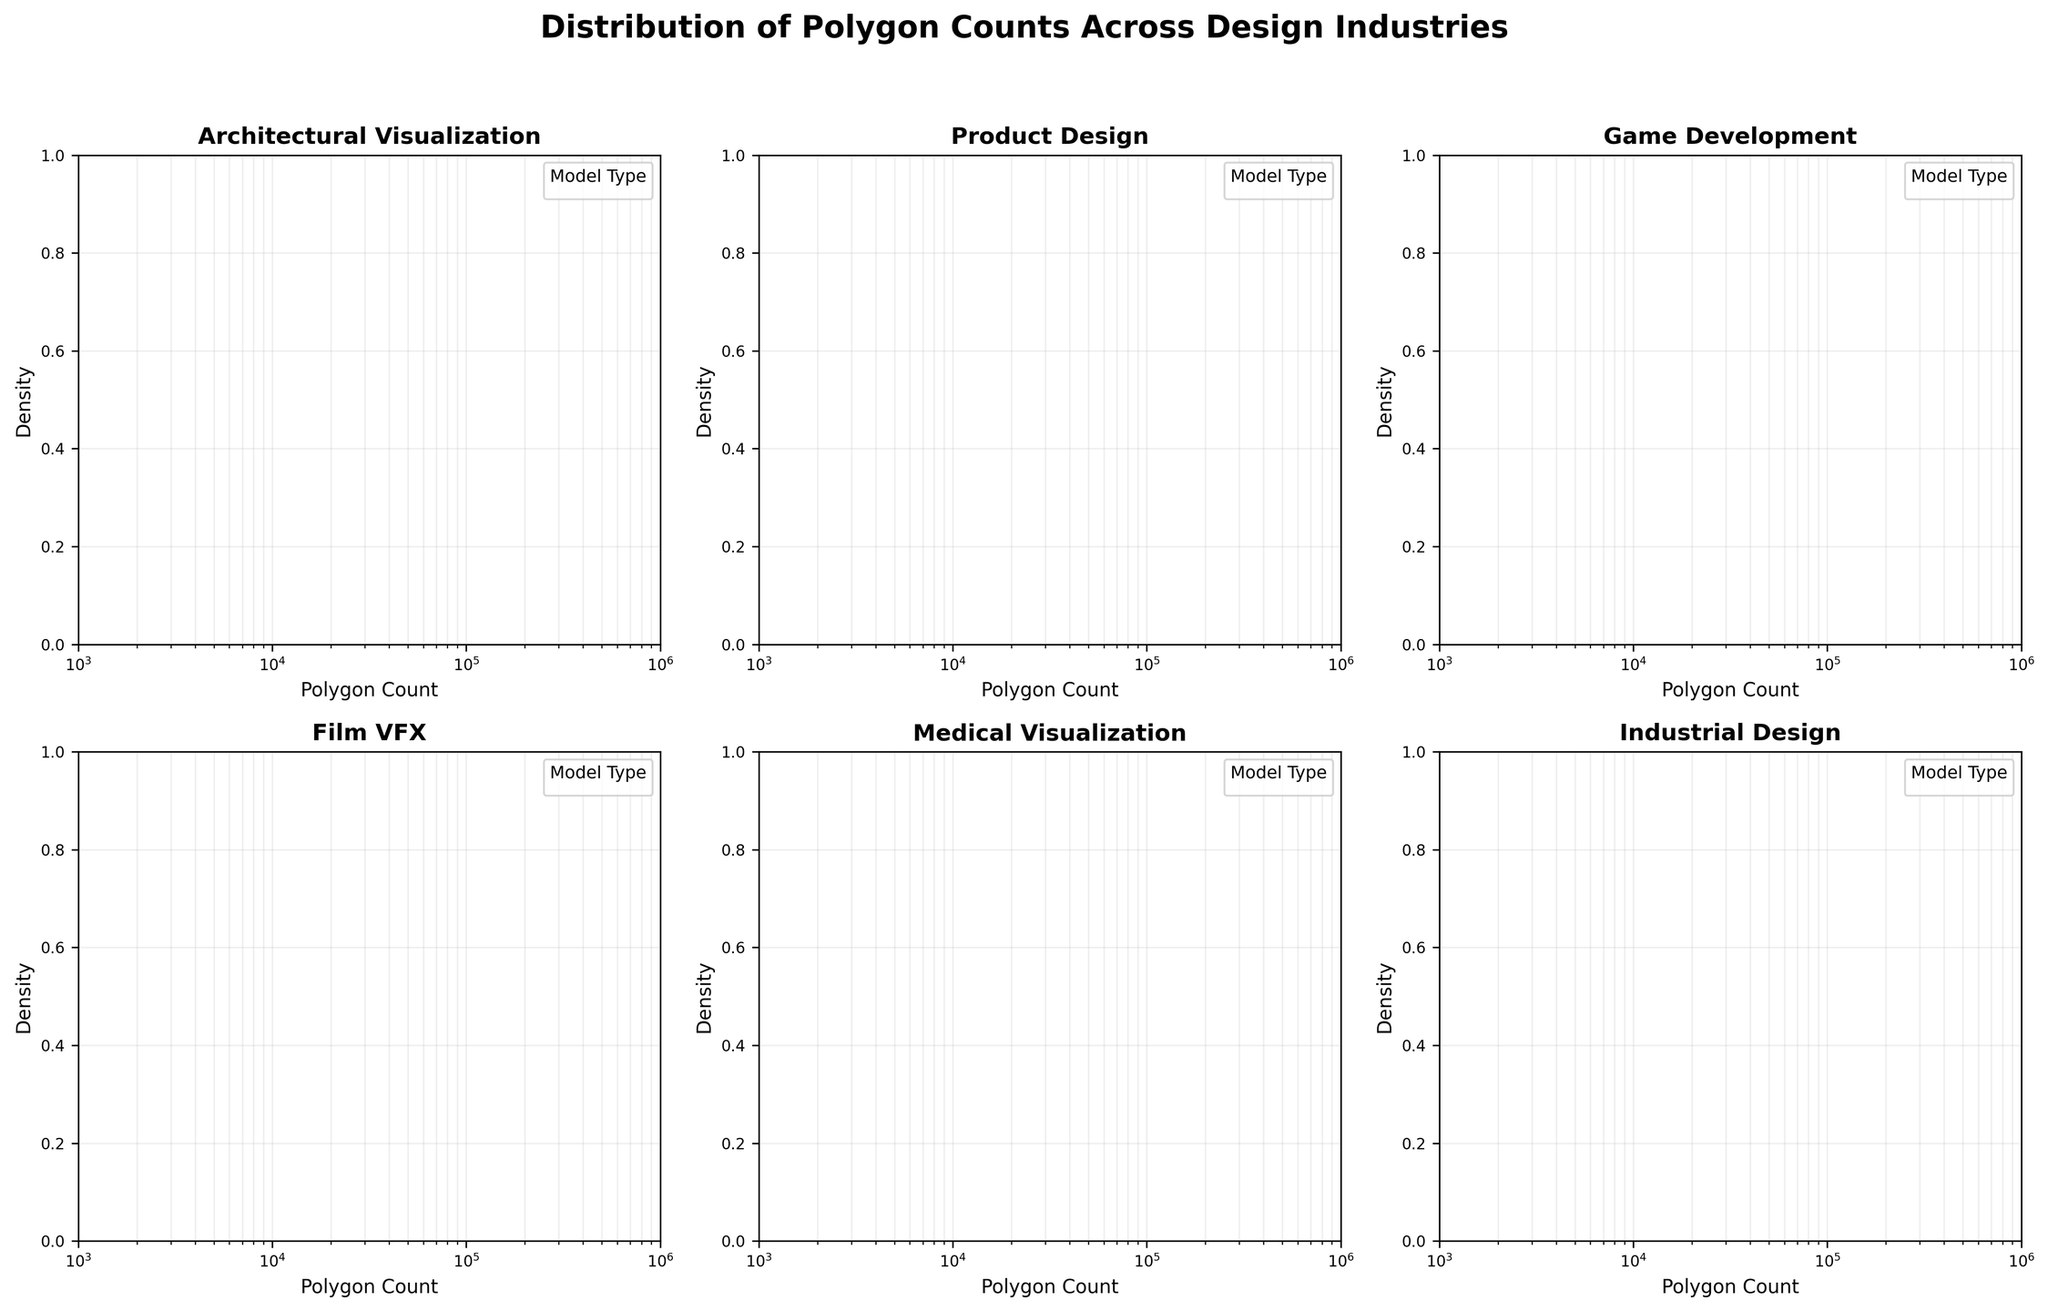What is the title of the overall figure? The title is located at the top center of the figure and reads 'Distribution of Polygon Counts Across Design Industries'.
Answer: Distribution of Polygon Counts Across Design Industries What industries are displayed in the subplots? The titles of the individual subplots indicate different industries: Architectural Visualization, Product Design, Game Development, Film VFX, Medical Visualization, and Industrial Design.
Answer: Architectural Visualization, Product Design, Game Development, Film VFX, Medical Visualization, Industrial Design Which industry has the model type with the highest polygon count? The Film VFX subplot shows the highest polygon count for the model type 'Complex Creature' with a count of 500,000.
Answer: Film VFX How does the spread of polygon counts in Game Development compare to those in Product Design? In the Game Development subplot, the polygon counts range from low-poly models at 2,000 to high-poly with 50,000, suggesting a wider range but lower overall polygon counts compared to Product Design, which ranges from 5,000 to 30,000.
Answer: Game Development has a wider but lower overall range What's the median polygon count range for Architectural Visualization models? In the Architectural Visualization subplot, the polygon counts for three model types appear roughly centered around 10,000, 25,000, and 50,000. Taking the middle value, the median polygon count is between 25,000 and 50,000.
Answer: Between 25,000 and 50,000 Which industry shows the largest variation in polygon counts between its models? The Film VFX subplot shows the largest variation ranging from 100,000 to 500,000 polygon counts in different model types.
Answer: Film VFX In terms of density, which industry has the most tightly clustered polygon counts? The Game Development subplot shows a denser clustering, especially around the low-poly character at 2,000 polygons and mid-poly environment at 10,000 polygons.
Answer: Game Development 